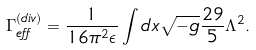<formula> <loc_0><loc_0><loc_500><loc_500>\Gamma ^ { ( d i v ) } _ { e f f } = \frac { 1 } { 1 6 \pi ^ { 2 } \epsilon } \int d x \sqrt { - g } \frac { 2 9 } { 5 } \Lambda ^ { 2 } .</formula> 